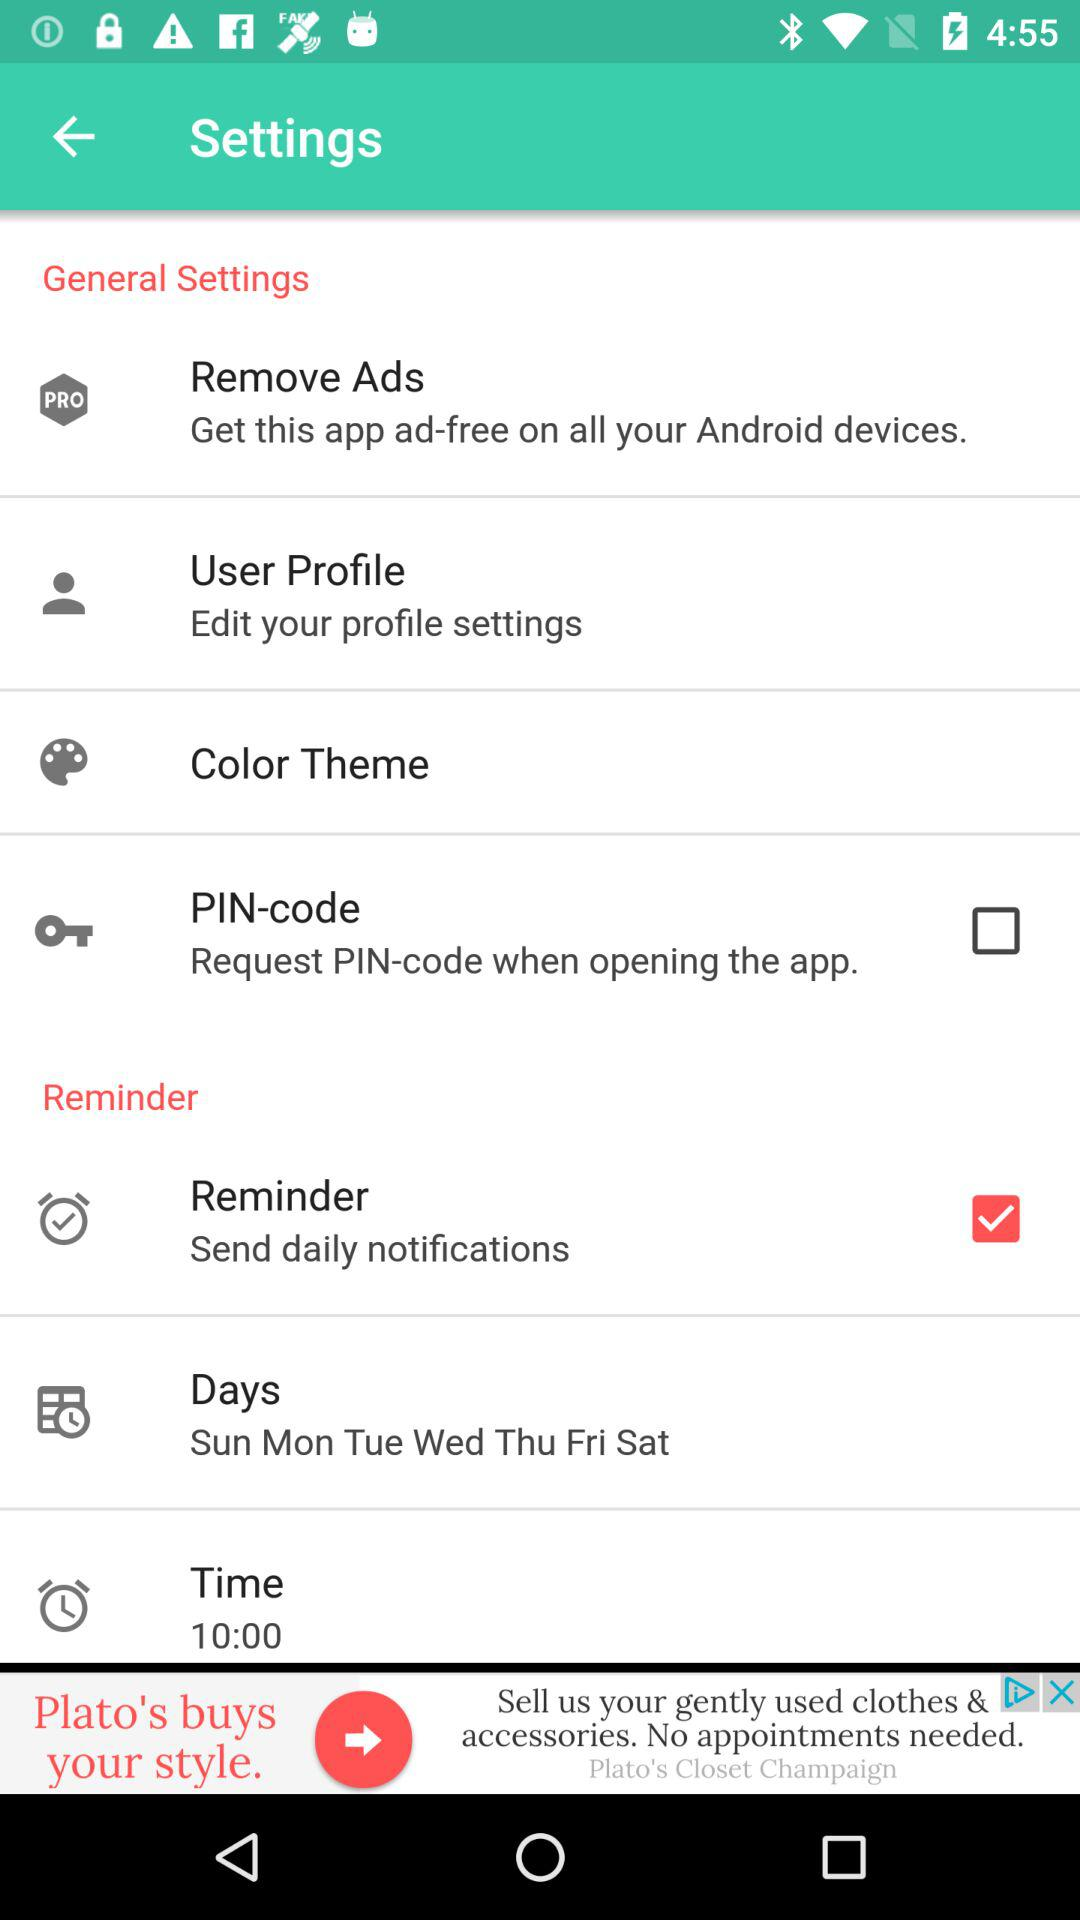How many items can be found under the General Settings section?
Answer the question using a single word or phrase. 4 